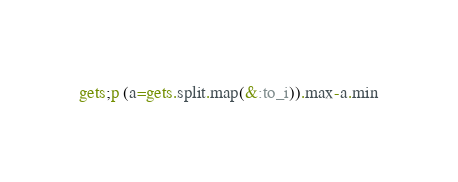Convert code to text. <code><loc_0><loc_0><loc_500><loc_500><_Ruby_>gets;p (a=gets.split.map(&:to_i)).max-a.min</code> 